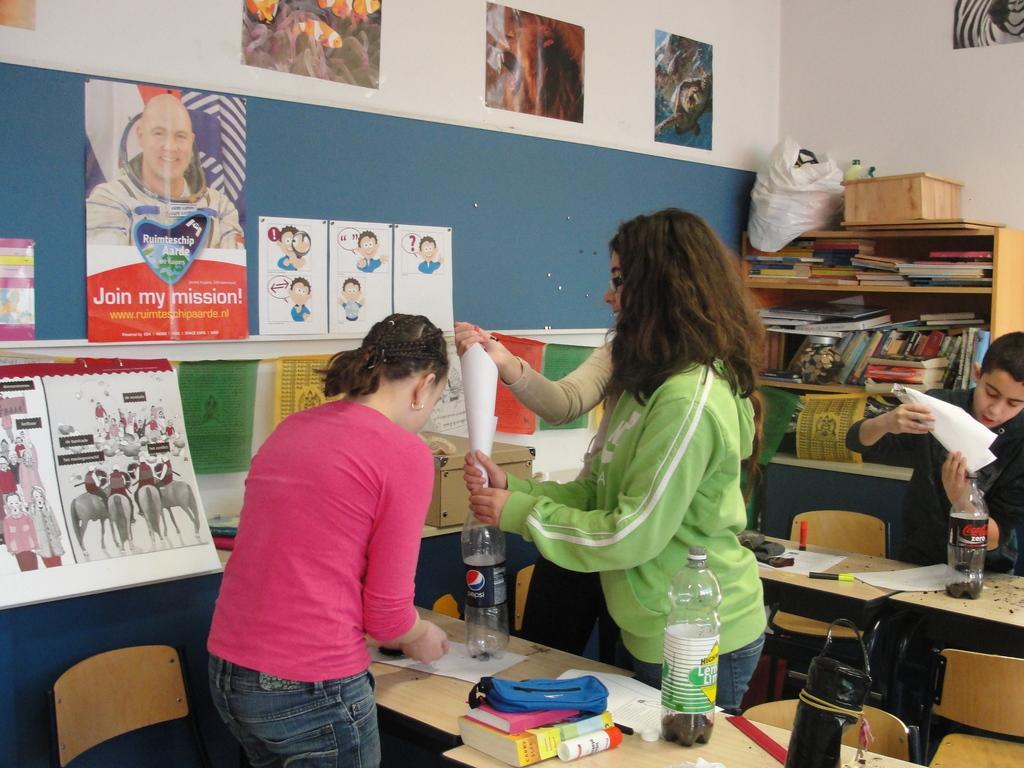Please provide a concise description of this image. In this picture we can see four people standing, three persons standing in front of a table, we can see some bottles on the table and also we can see a handbag and a book on the table, in the background we can see some charts which are stick to wall and also we can see a cupboard, there are some bunch of books which are placed on the rack. 